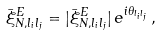<formula> <loc_0><loc_0><loc_500><loc_500>\bar { \xi } _ { N , l _ { i } l _ { j } } ^ { E } = | \bar { \xi } _ { N , l _ { i } l _ { j } } ^ { E } | \, e ^ { i \theta _ { l _ { i } l _ { j } } } \, ,</formula> 